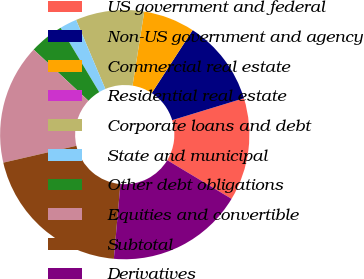<chart> <loc_0><loc_0><loc_500><loc_500><pie_chart><fcel>US government and federal<fcel>Non-US government and agency<fcel>Commercial real estate<fcel>Residential real estate<fcel>Corporate loans and debt<fcel>State and municipal<fcel>Other debt obligations<fcel>Equities and convertible<fcel>Subtotal<fcel>Derivatives<nl><fcel>13.33%<fcel>11.11%<fcel>6.67%<fcel>0.0%<fcel>8.89%<fcel>2.22%<fcel>4.44%<fcel>15.56%<fcel>20.0%<fcel>17.78%<nl></chart> 